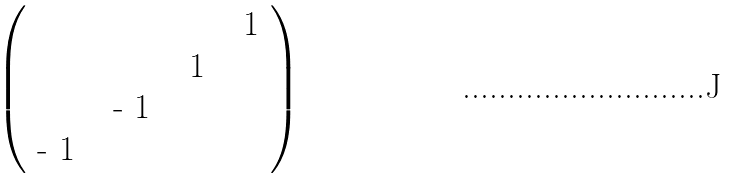<formula> <loc_0><loc_0><loc_500><loc_500>\begin{pmatrix} & & & $ 1 $ \\ & & $ 1 $ & \\ & $ - 1 $ & & \\ $ - 1 $ & & & \\ \end{pmatrix}</formula> 